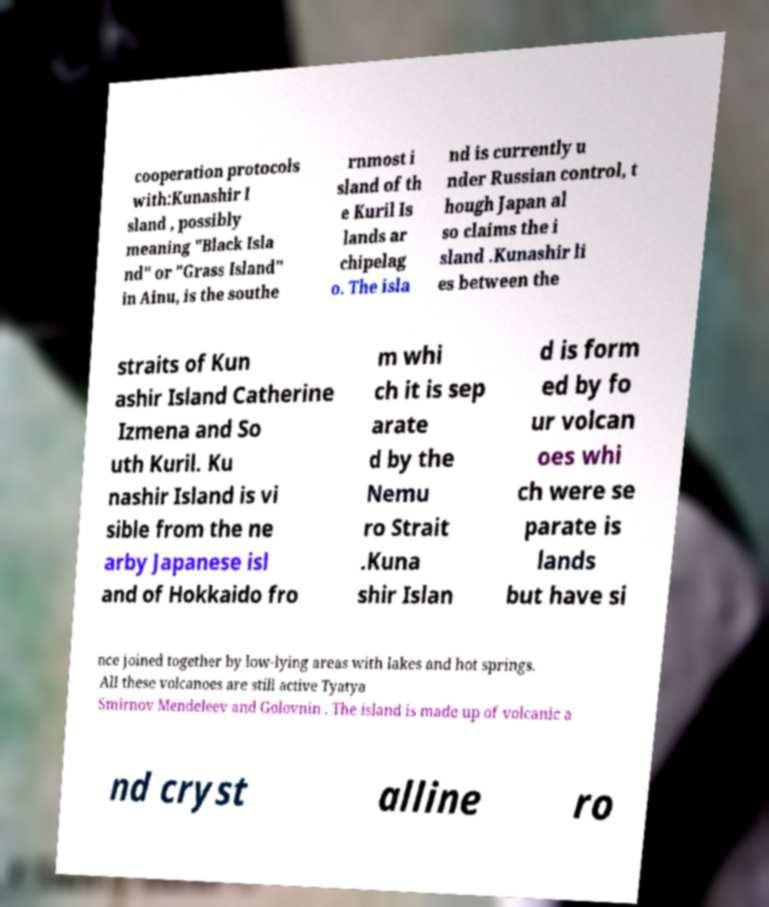I need the written content from this picture converted into text. Can you do that? cooperation protocols with:Kunashir I sland , possibly meaning "Black Isla nd" or "Grass Island" in Ainu, is the southe rnmost i sland of th e Kuril Is lands ar chipelag o. The isla nd is currently u nder Russian control, t hough Japan al so claims the i sland .Kunashir li es between the straits of Kun ashir Island Catherine Izmena and So uth Kuril. Ku nashir Island is vi sible from the ne arby Japanese isl and of Hokkaido fro m whi ch it is sep arate d by the Nemu ro Strait .Kuna shir Islan d is form ed by fo ur volcan oes whi ch were se parate is lands but have si nce joined together by low-lying areas with lakes and hot springs. All these volcanoes are still active Tyatya Smirnov Mendeleev and Golovnin . The island is made up of volcanic a nd cryst alline ro 